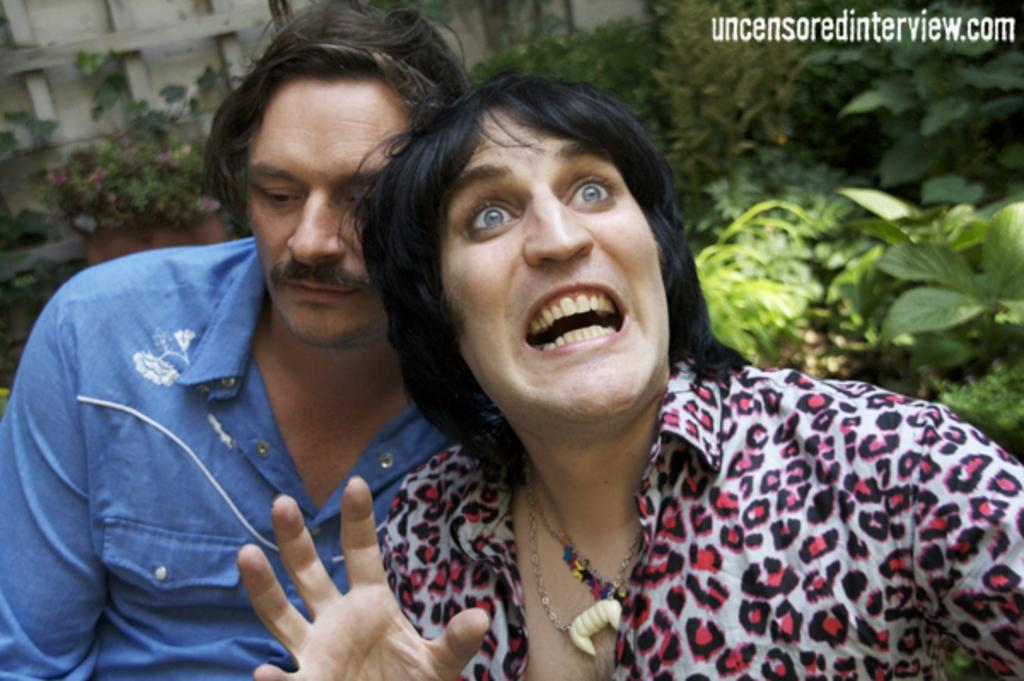How many people are in the foreground of the image? There are two persons in the foreground of the image. What can be seen in the background of the image? In the background of the image, there are flowers to plant and a group of trees. What is placed on the wall in the background of the image? Wood pieces are placed on the wall in the background of the image. Can you see the sea in the image? No, the sea is not present in the image. Is there a stove visible in the image? No, there is no stove present in the image. 